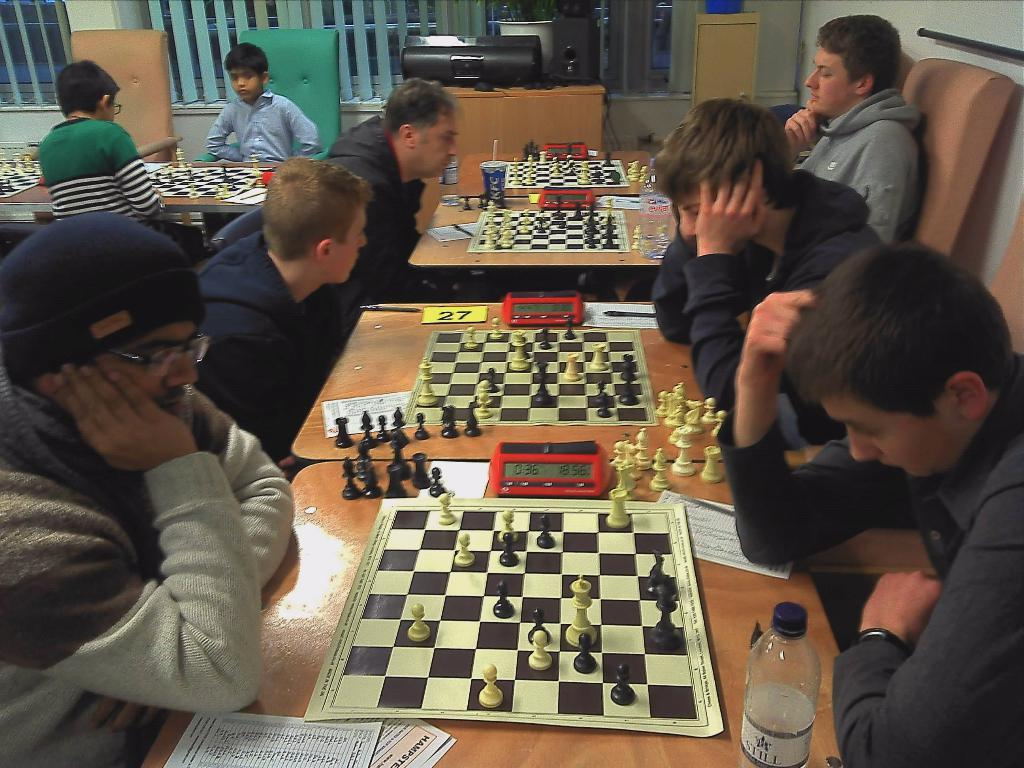How many people are in the image? There is a group of people in the image. What are the people doing in the image? The people are sitting on chairs and playing chess on a table. What can be seen on the table besides the chessboard? There is a water bottle and papers on the table. What type of banana is being used as a chess piece in the image? There are no bananas present in the image. 